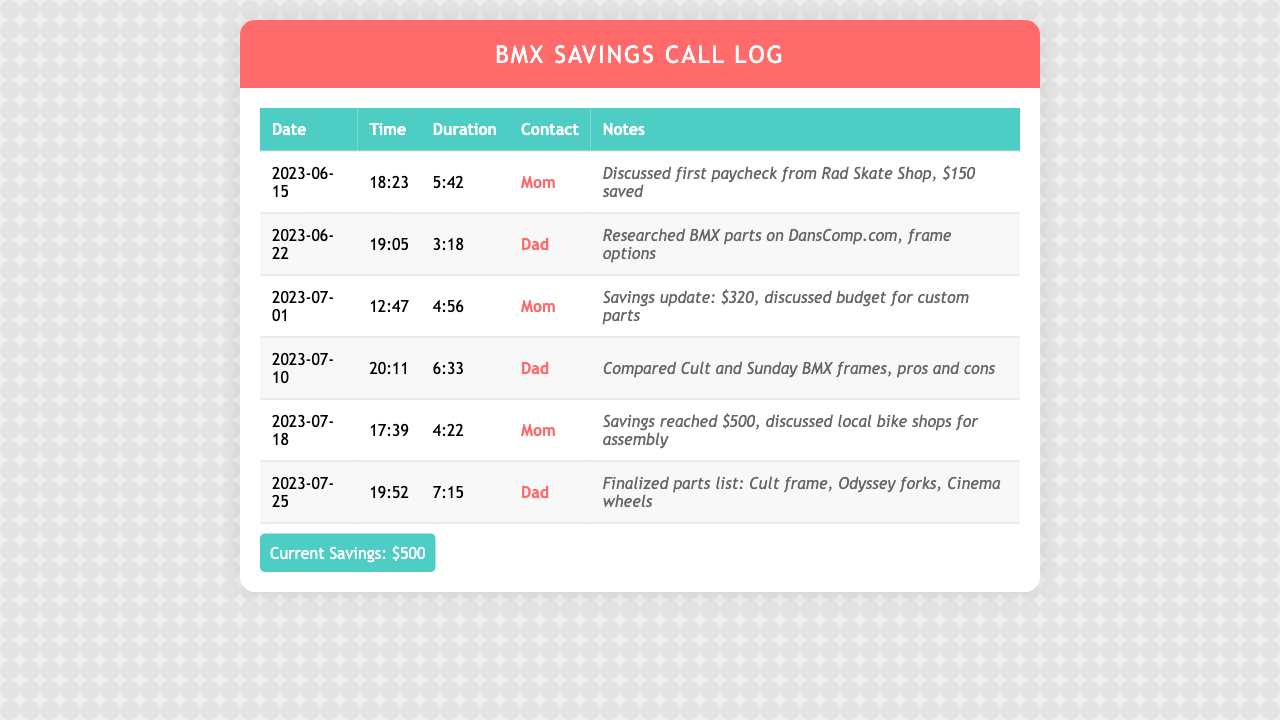What is the date of the first call? The first call is listed on June 15, 2023.
Answer: June 15, 2023 How much did you save after the first paycheck? The first paycheck's savings discussed was $150.
Answer: $150 What was the savings amount discussed on July 1? On July 1, the savings amount discussed was $320.
Answer: $320 Who was the main contact for the last call? The last call was with Dad.
Answer: Dad What is the total savings reached by July 18? By July 18, the total savings reached was $500.
Answer: $500 Which bike parts were finalized in the call on July 25? The finalized parts list included a Cult frame, Odyssey forks, and Cinema wheels.
Answer: Cult frame, Odyssey forks, Cinema wheels What was the duration of the call with Mom on July 18? The duration of the call with Mom on July 18 was 4:22.
Answer: 4:22 How many times did Mom appear as a contact in the log? Mom appeared as a contact three times in the log.
Answer: Three times What did the call on June 22 focus on? The call on June 22 focused on researching BMX parts on DansComp.com.
Answer: Researching BMX parts 